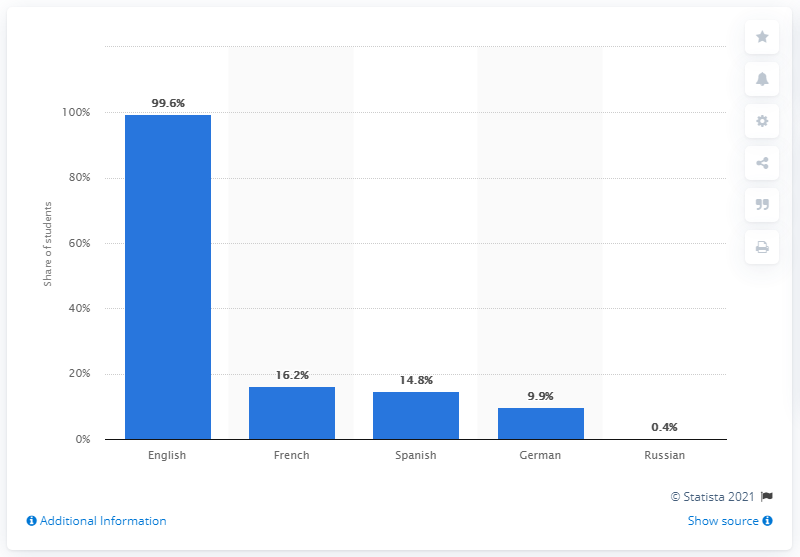Draw attention to some important aspects in this diagram. German was the fourth most commonly studied foreign language in Italian high schools. According to the data, it was found that 16.2% of Italian high school students studied French and Spanish. In 2019, Italian schools reported that English was the language that was most extensively studied. A small percentage of Italian high school students studied Russian as a language. 